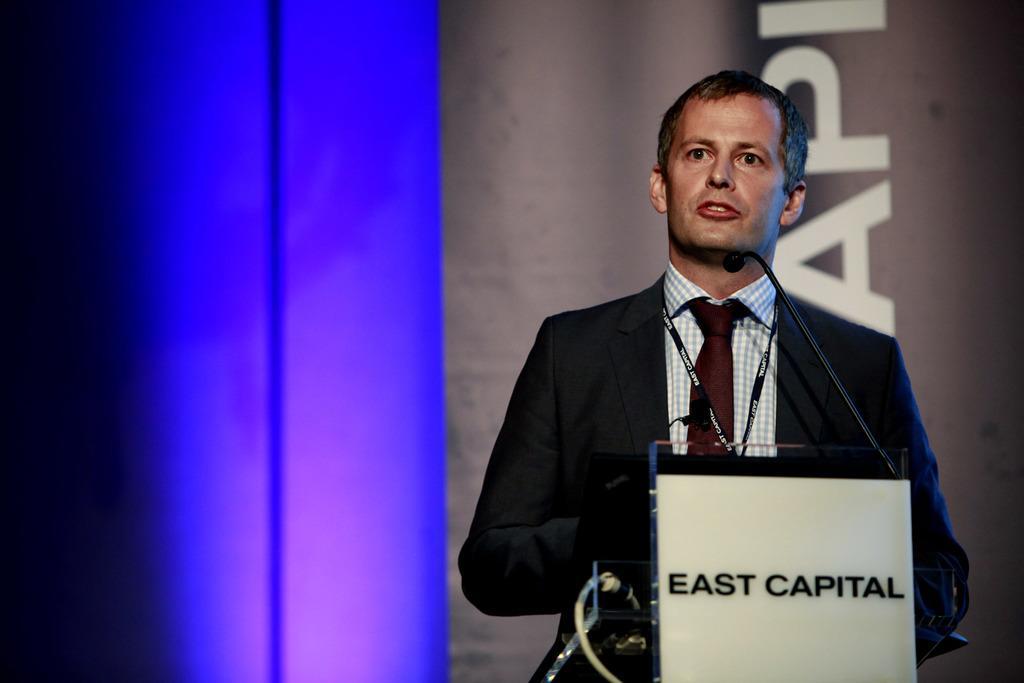In one or two sentences, can you explain what this image depicts? On the right side of the image we can see a man standing. He is wearing a suit, before him there is a podium and we can see a mic placed on the podium. In the background there is a board and we can see a light. 